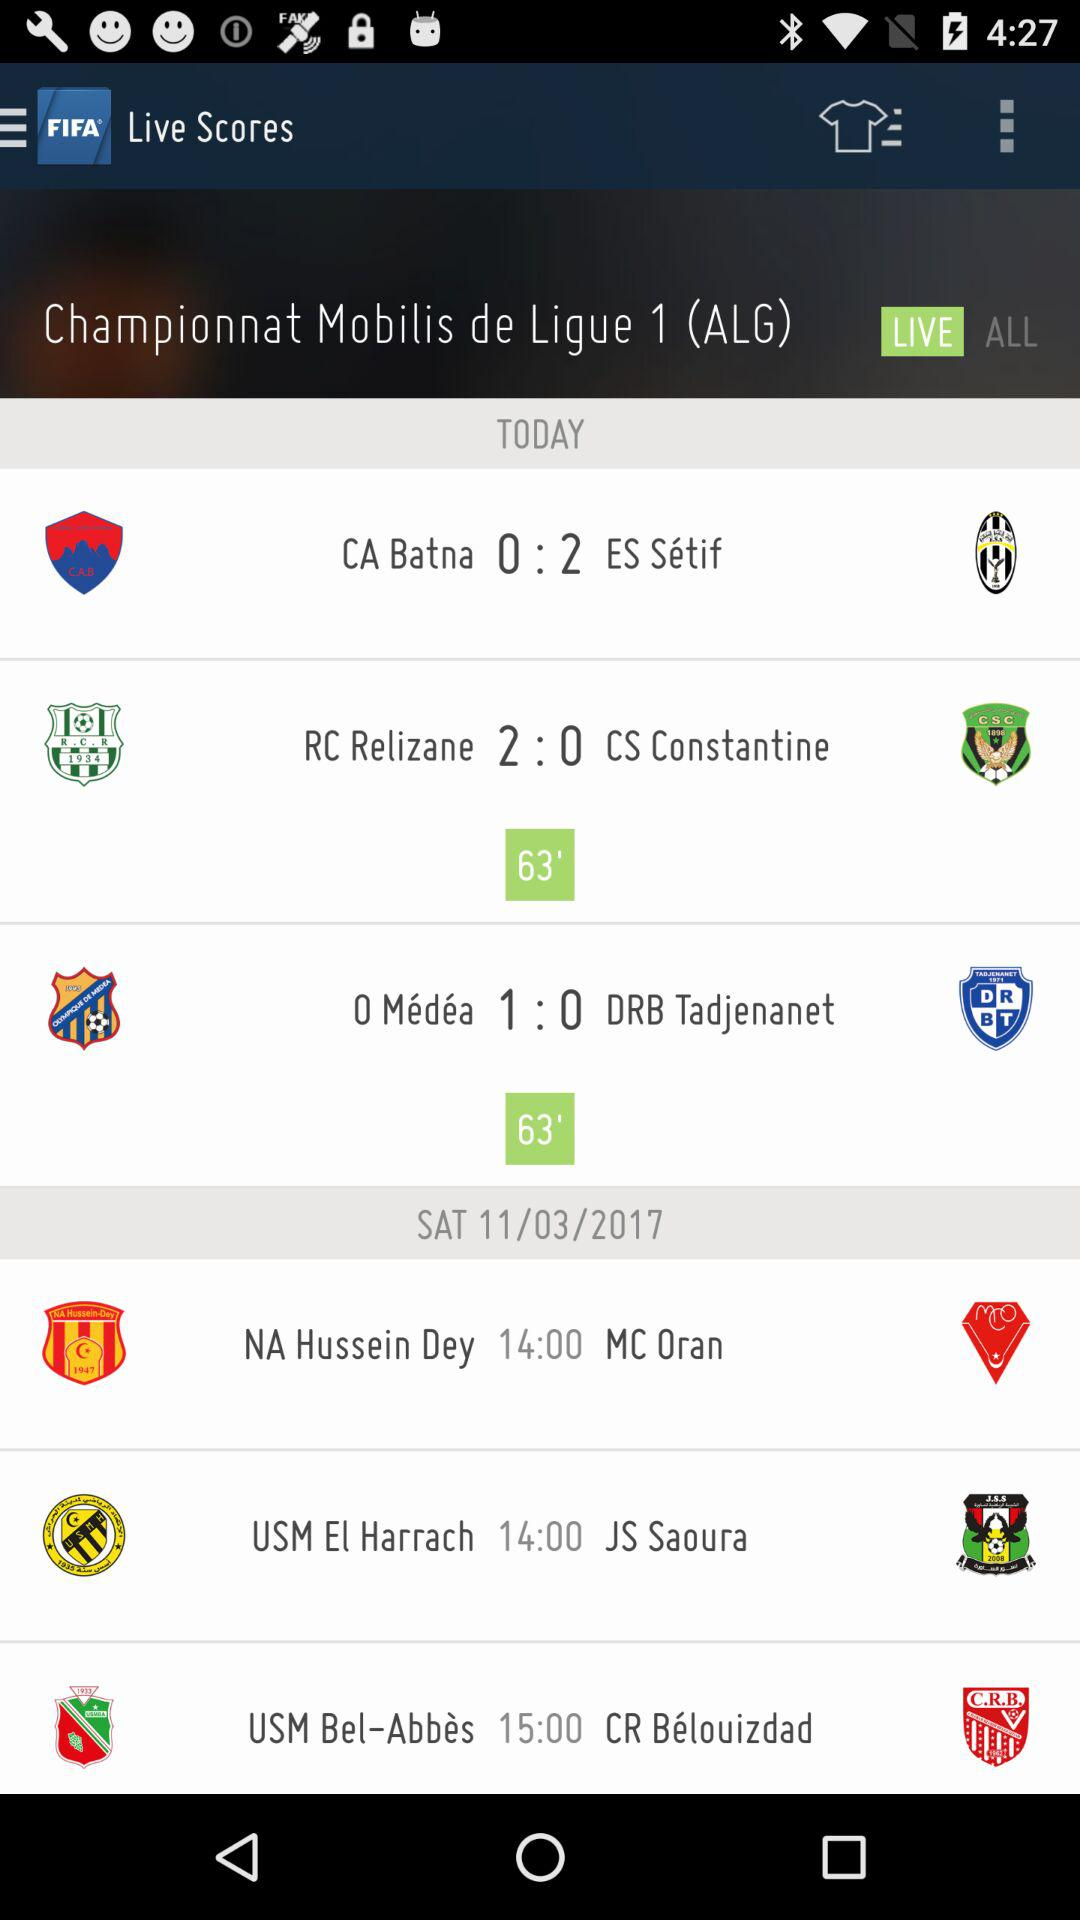What is the date on Saturday? The date is 11/03/2017. 